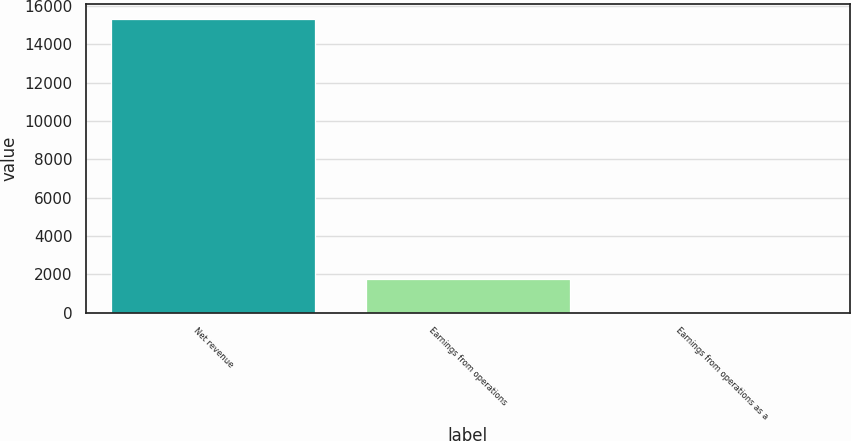Convert chart to OTSL. <chart><loc_0><loc_0><loc_500><loc_500><bar_chart><fcel>Net revenue<fcel>Earnings from operations<fcel>Earnings from operations as a<nl><fcel>15329<fcel>1782<fcel>11.6<nl></chart> 